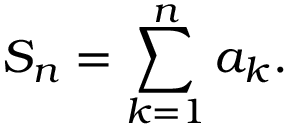<formula> <loc_0><loc_0><loc_500><loc_500>S _ { n } = \sum _ { k = 1 } ^ { n } a _ { k } .</formula> 